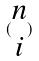<formula> <loc_0><loc_0><loc_500><loc_500>( \begin{matrix} n \\ i \end{matrix} )</formula> 